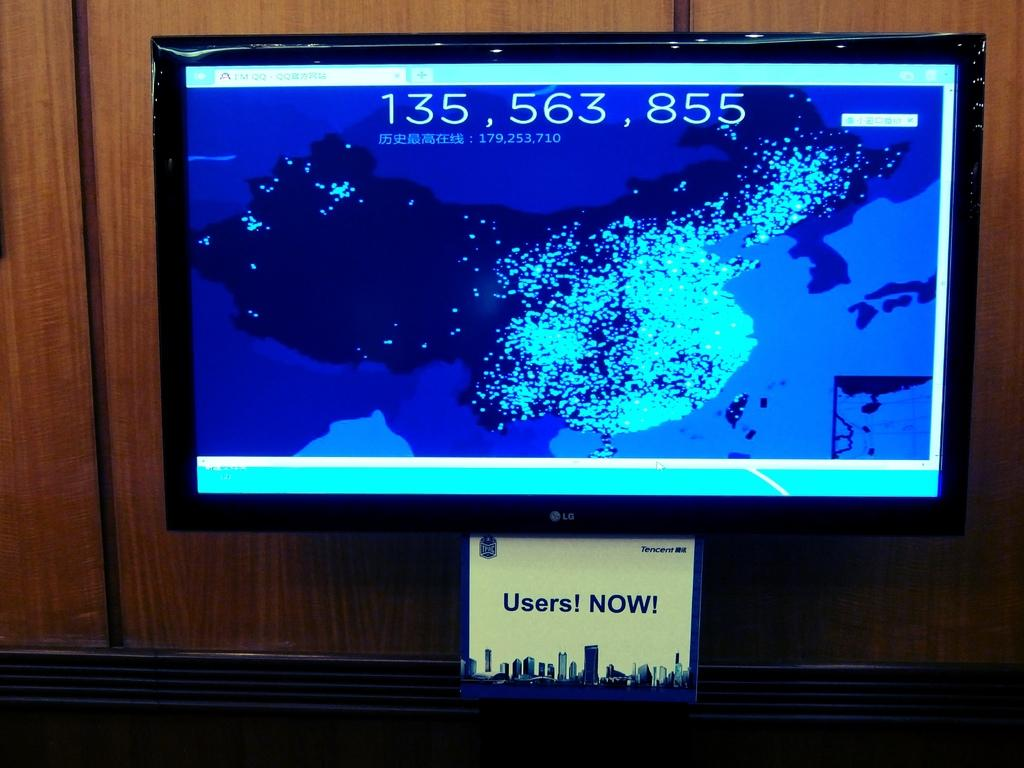<image>
Present a compact description of the photo's key features. A computer monitor with a picture of China and the number 135,563,855 at the top. 